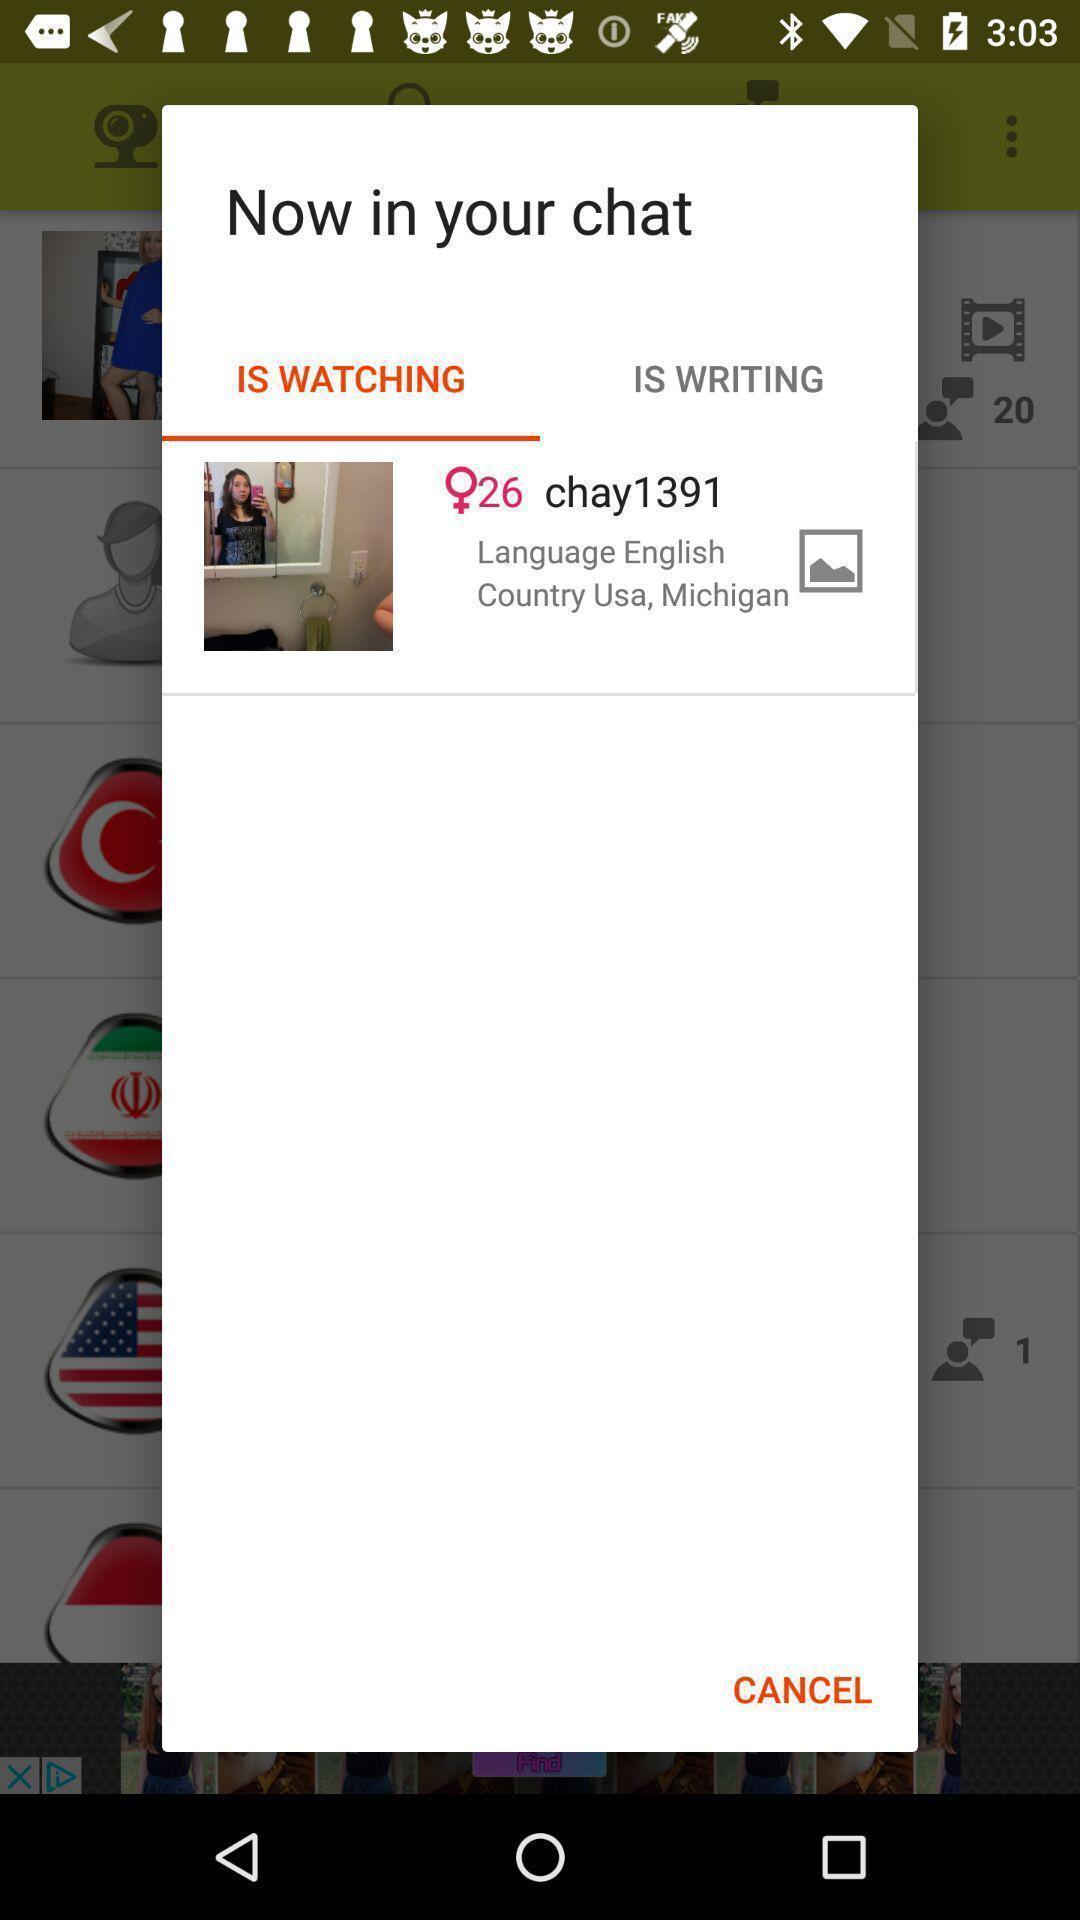Explain the elements present in this screenshot. Popup of new participant in your chat. 